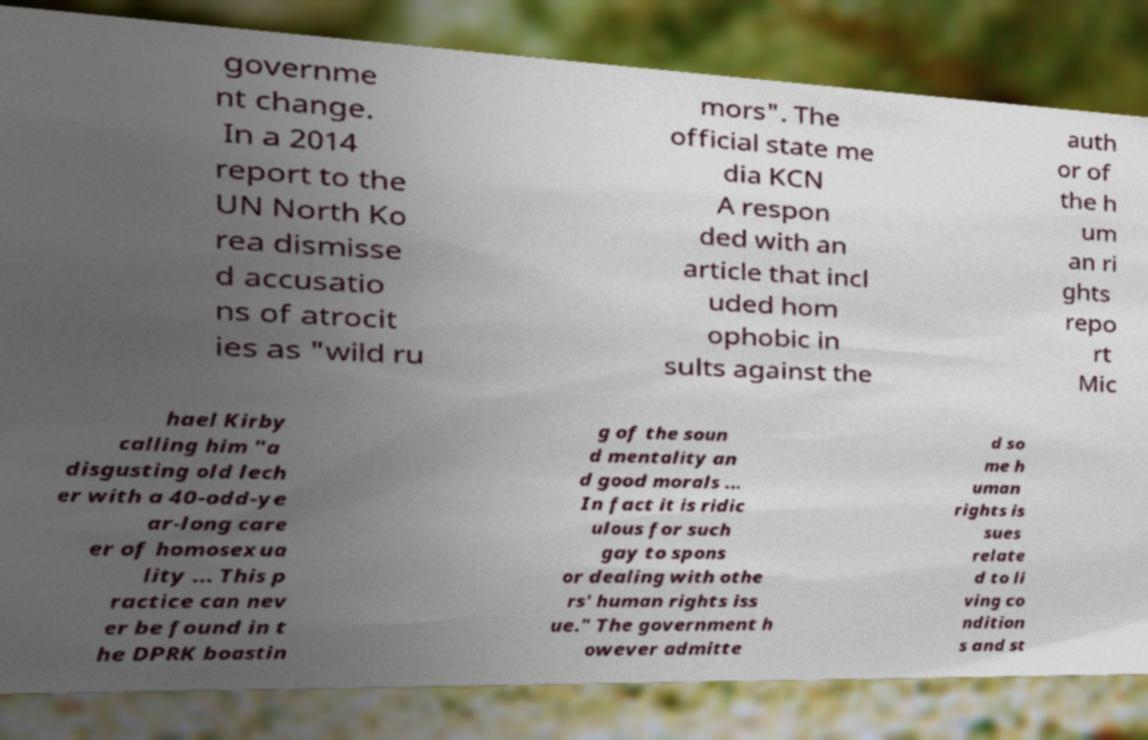What messages or text are displayed in this image? I need them in a readable, typed format. governme nt change. In a 2014 report to the UN North Ko rea dismisse d accusatio ns of atrocit ies as "wild ru mors". The official state me dia KCN A respon ded with an article that incl uded hom ophobic in sults against the auth or of the h um an ri ghts repo rt Mic hael Kirby calling him "a disgusting old lech er with a 40-odd-ye ar-long care er of homosexua lity ... This p ractice can nev er be found in t he DPRK boastin g of the soun d mentality an d good morals ... In fact it is ridic ulous for such gay to spons or dealing with othe rs' human rights iss ue." The government h owever admitte d so me h uman rights is sues relate d to li ving co ndition s and st 